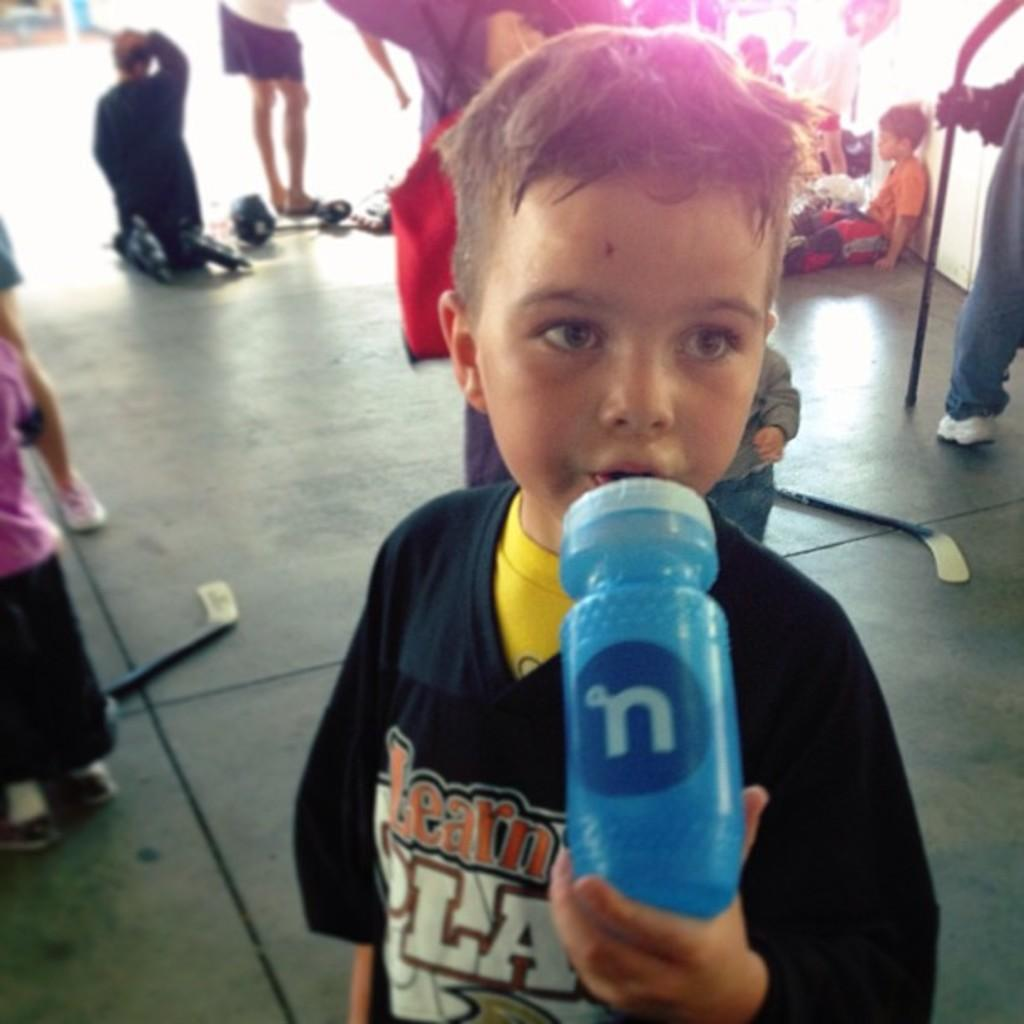How many people are in the image? There are people in the image, but the exact number is not specified. What are some of the people doing in the image? Some of the people are sitting on the floor, while others are standing on the floor. Can you describe the positions of the people in the image? Some people are sitting, while others are standing. What type of leaf is being used as a shock absorber by the laborer in the image? There is no laborer or leaf present in the image. 